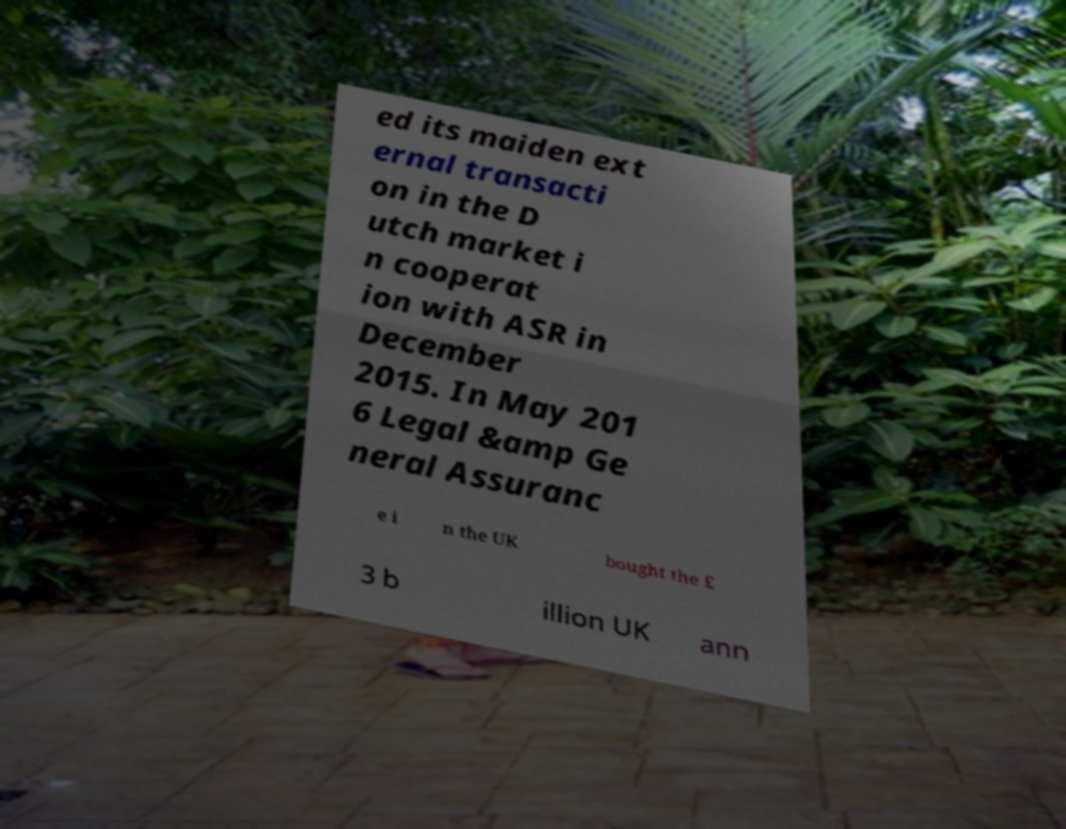There's text embedded in this image that I need extracted. Can you transcribe it verbatim? ed its maiden ext ernal transacti on in the D utch market i n cooperat ion with ASR in December 2015. In May 201 6 Legal &amp Ge neral Assuranc e i n the UK bought the £ 3 b illion UK ann 